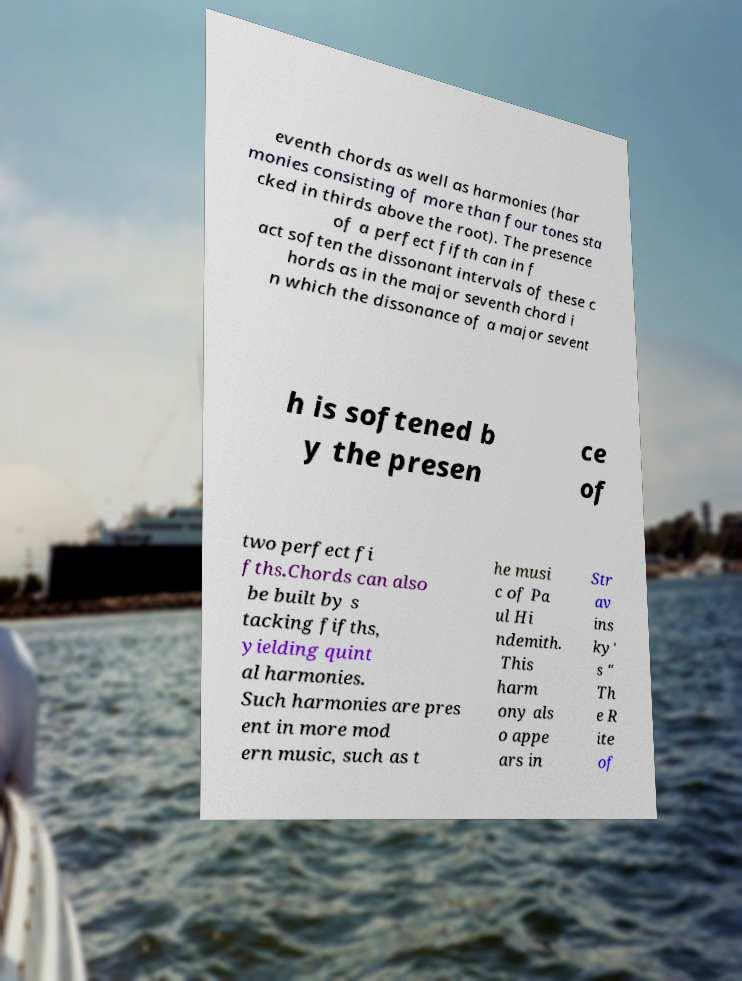There's text embedded in this image that I need extracted. Can you transcribe it verbatim? eventh chords as well as harmonies (har monies consisting of more than four tones sta cked in thirds above the root). The presence of a perfect fifth can in f act soften the dissonant intervals of these c hords as in the major seventh chord i n which the dissonance of a major sevent h is softened b y the presen ce of two perfect fi fths.Chords can also be built by s tacking fifths, yielding quint al harmonies. Such harmonies are pres ent in more mod ern music, such as t he musi c of Pa ul Hi ndemith. This harm ony als o appe ars in Str av ins ky' s " Th e R ite of 